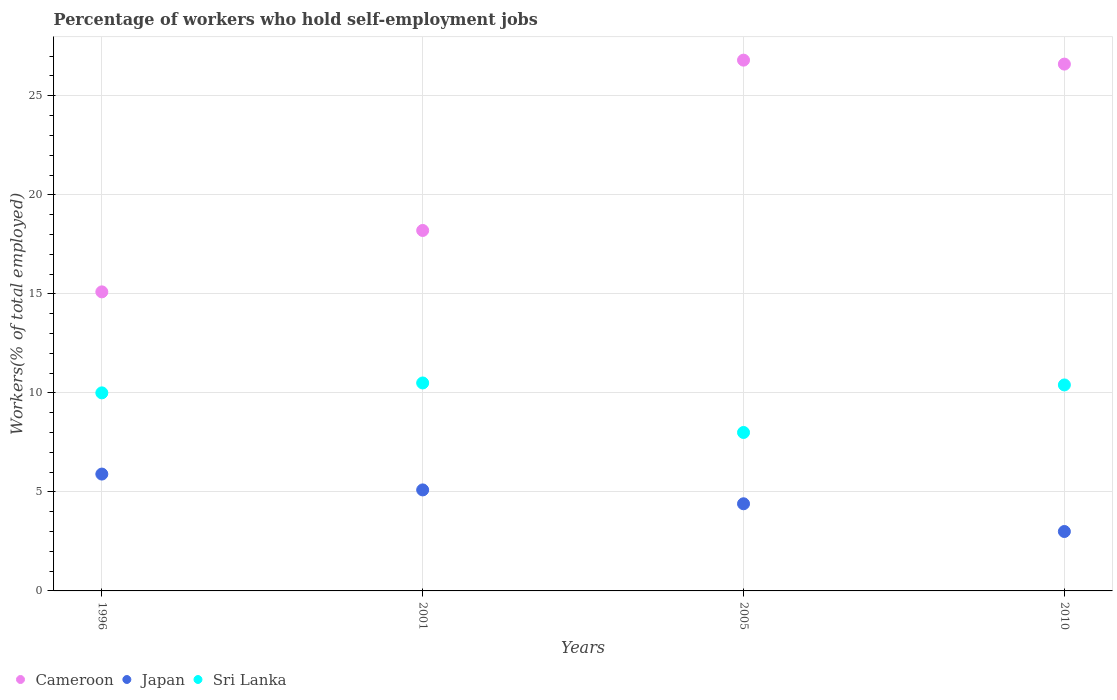Is the number of dotlines equal to the number of legend labels?
Ensure brevity in your answer.  Yes. What is the percentage of self-employed workers in Cameroon in 2010?
Your response must be concise. 26.6. Across all years, what is the maximum percentage of self-employed workers in Japan?
Provide a succinct answer. 5.9. Across all years, what is the minimum percentage of self-employed workers in Cameroon?
Your answer should be very brief. 15.1. In which year was the percentage of self-employed workers in Japan maximum?
Offer a very short reply. 1996. In which year was the percentage of self-employed workers in Japan minimum?
Your answer should be very brief. 2010. What is the total percentage of self-employed workers in Sri Lanka in the graph?
Ensure brevity in your answer.  38.9. What is the difference between the percentage of self-employed workers in Sri Lanka in 2001 and that in 2010?
Your answer should be very brief. 0.1. What is the difference between the percentage of self-employed workers in Cameroon in 2001 and the percentage of self-employed workers in Sri Lanka in 1996?
Your answer should be very brief. 8.2. What is the average percentage of self-employed workers in Japan per year?
Give a very brief answer. 4.6. In the year 2005, what is the difference between the percentage of self-employed workers in Sri Lanka and percentage of self-employed workers in Japan?
Your response must be concise. 3.6. In how many years, is the percentage of self-employed workers in Cameroon greater than 14 %?
Ensure brevity in your answer.  4. What is the ratio of the percentage of self-employed workers in Cameroon in 1996 to that in 2005?
Keep it short and to the point. 0.56. Is the difference between the percentage of self-employed workers in Sri Lanka in 2001 and 2010 greater than the difference between the percentage of self-employed workers in Japan in 2001 and 2010?
Provide a short and direct response. No. What is the difference between the highest and the second highest percentage of self-employed workers in Sri Lanka?
Make the answer very short. 0.1. What is the difference between the highest and the lowest percentage of self-employed workers in Cameroon?
Make the answer very short. 11.7. In how many years, is the percentage of self-employed workers in Japan greater than the average percentage of self-employed workers in Japan taken over all years?
Give a very brief answer. 2. Is the sum of the percentage of self-employed workers in Japan in 1996 and 2001 greater than the maximum percentage of self-employed workers in Sri Lanka across all years?
Offer a very short reply. Yes. Does the percentage of self-employed workers in Cameroon monotonically increase over the years?
Keep it short and to the point. No. Is the percentage of self-employed workers in Japan strictly greater than the percentage of self-employed workers in Sri Lanka over the years?
Offer a very short reply. No. How many dotlines are there?
Offer a terse response. 3. How many years are there in the graph?
Keep it short and to the point. 4. Does the graph contain any zero values?
Your response must be concise. No. Does the graph contain grids?
Provide a succinct answer. Yes. Where does the legend appear in the graph?
Provide a succinct answer. Bottom left. How many legend labels are there?
Offer a terse response. 3. How are the legend labels stacked?
Ensure brevity in your answer.  Horizontal. What is the title of the graph?
Your response must be concise. Percentage of workers who hold self-employment jobs. Does "Brazil" appear as one of the legend labels in the graph?
Offer a terse response. No. What is the label or title of the Y-axis?
Offer a very short reply. Workers(% of total employed). What is the Workers(% of total employed) of Cameroon in 1996?
Give a very brief answer. 15.1. What is the Workers(% of total employed) of Japan in 1996?
Your answer should be very brief. 5.9. What is the Workers(% of total employed) of Sri Lanka in 1996?
Give a very brief answer. 10. What is the Workers(% of total employed) of Cameroon in 2001?
Provide a succinct answer. 18.2. What is the Workers(% of total employed) of Japan in 2001?
Give a very brief answer. 5.1. What is the Workers(% of total employed) of Sri Lanka in 2001?
Your response must be concise. 10.5. What is the Workers(% of total employed) in Cameroon in 2005?
Offer a very short reply. 26.8. What is the Workers(% of total employed) of Japan in 2005?
Make the answer very short. 4.4. What is the Workers(% of total employed) in Sri Lanka in 2005?
Your answer should be very brief. 8. What is the Workers(% of total employed) of Cameroon in 2010?
Your response must be concise. 26.6. What is the Workers(% of total employed) of Sri Lanka in 2010?
Offer a very short reply. 10.4. Across all years, what is the maximum Workers(% of total employed) of Cameroon?
Provide a short and direct response. 26.8. Across all years, what is the maximum Workers(% of total employed) in Japan?
Provide a succinct answer. 5.9. Across all years, what is the minimum Workers(% of total employed) of Cameroon?
Offer a very short reply. 15.1. Across all years, what is the minimum Workers(% of total employed) in Japan?
Offer a terse response. 3. Across all years, what is the minimum Workers(% of total employed) of Sri Lanka?
Give a very brief answer. 8. What is the total Workers(% of total employed) in Cameroon in the graph?
Provide a short and direct response. 86.7. What is the total Workers(% of total employed) of Japan in the graph?
Make the answer very short. 18.4. What is the total Workers(% of total employed) in Sri Lanka in the graph?
Offer a very short reply. 38.9. What is the difference between the Workers(% of total employed) in Cameroon in 1996 and that in 2001?
Your answer should be very brief. -3.1. What is the difference between the Workers(% of total employed) in Sri Lanka in 1996 and that in 2001?
Give a very brief answer. -0.5. What is the difference between the Workers(% of total employed) of Cameroon in 1996 and that in 2005?
Provide a succinct answer. -11.7. What is the difference between the Workers(% of total employed) of Japan in 1996 and that in 2005?
Your answer should be compact. 1.5. What is the difference between the Workers(% of total employed) of Sri Lanka in 1996 and that in 2010?
Give a very brief answer. -0.4. What is the difference between the Workers(% of total employed) in Sri Lanka in 2001 and that in 2005?
Your response must be concise. 2.5. What is the difference between the Workers(% of total employed) in Cameroon in 2001 and that in 2010?
Provide a short and direct response. -8.4. What is the difference between the Workers(% of total employed) in Japan in 2001 and that in 2010?
Your answer should be compact. 2.1. What is the difference between the Workers(% of total employed) in Sri Lanka in 2001 and that in 2010?
Your answer should be very brief. 0.1. What is the difference between the Workers(% of total employed) in Cameroon in 1996 and the Workers(% of total employed) in Japan in 2001?
Your response must be concise. 10. What is the difference between the Workers(% of total employed) of Cameroon in 1996 and the Workers(% of total employed) of Japan in 2005?
Make the answer very short. 10.7. What is the difference between the Workers(% of total employed) in Japan in 1996 and the Workers(% of total employed) in Sri Lanka in 2005?
Your answer should be very brief. -2.1. What is the difference between the Workers(% of total employed) in Japan in 1996 and the Workers(% of total employed) in Sri Lanka in 2010?
Make the answer very short. -4.5. What is the difference between the Workers(% of total employed) in Japan in 2001 and the Workers(% of total employed) in Sri Lanka in 2005?
Make the answer very short. -2.9. What is the difference between the Workers(% of total employed) in Cameroon in 2001 and the Workers(% of total employed) in Sri Lanka in 2010?
Provide a short and direct response. 7.8. What is the difference between the Workers(% of total employed) of Cameroon in 2005 and the Workers(% of total employed) of Japan in 2010?
Provide a short and direct response. 23.8. What is the difference between the Workers(% of total employed) in Cameroon in 2005 and the Workers(% of total employed) in Sri Lanka in 2010?
Offer a terse response. 16.4. What is the average Workers(% of total employed) in Cameroon per year?
Offer a terse response. 21.68. What is the average Workers(% of total employed) of Japan per year?
Offer a terse response. 4.6. What is the average Workers(% of total employed) in Sri Lanka per year?
Your response must be concise. 9.72. In the year 1996, what is the difference between the Workers(% of total employed) in Cameroon and Workers(% of total employed) in Sri Lanka?
Your response must be concise. 5.1. In the year 1996, what is the difference between the Workers(% of total employed) of Japan and Workers(% of total employed) of Sri Lanka?
Make the answer very short. -4.1. In the year 2001, what is the difference between the Workers(% of total employed) of Cameroon and Workers(% of total employed) of Sri Lanka?
Provide a succinct answer. 7.7. In the year 2001, what is the difference between the Workers(% of total employed) in Japan and Workers(% of total employed) in Sri Lanka?
Provide a short and direct response. -5.4. In the year 2005, what is the difference between the Workers(% of total employed) of Cameroon and Workers(% of total employed) of Japan?
Offer a terse response. 22.4. In the year 2010, what is the difference between the Workers(% of total employed) of Cameroon and Workers(% of total employed) of Japan?
Ensure brevity in your answer.  23.6. In the year 2010, what is the difference between the Workers(% of total employed) of Japan and Workers(% of total employed) of Sri Lanka?
Give a very brief answer. -7.4. What is the ratio of the Workers(% of total employed) in Cameroon in 1996 to that in 2001?
Your response must be concise. 0.83. What is the ratio of the Workers(% of total employed) in Japan in 1996 to that in 2001?
Your answer should be very brief. 1.16. What is the ratio of the Workers(% of total employed) in Cameroon in 1996 to that in 2005?
Make the answer very short. 0.56. What is the ratio of the Workers(% of total employed) of Japan in 1996 to that in 2005?
Give a very brief answer. 1.34. What is the ratio of the Workers(% of total employed) of Cameroon in 1996 to that in 2010?
Keep it short and to the point. 0.57. What is the ratio of the Workers(% of total employed) of Japan in 1996 to that in 2010?
Your answer should be compact. 1.97. What is the ratio of the Workers(% of total employed) of Sri Lanka in 1996 to that in 2010?
Provide a succinct answer. 0.96. What is the ratio of the Workers(% of total employed) of Cameroon in 2001 to that in 2005?
Provide a succinct answer. 0.68. What is the ratio of the Workers(% of total employed) in Japan in 2001 to that in 2005?
Your answer should be compact. 1.16. What is the ratio of the Workers(% of total employed) of Sri Lanka in 2001 to that in 2005?
Provide a succinct answer. 1.31. What is the ratio of the Workers(% of total employed) in Cameroon in 2001 to that in 2010?
Offer a very short reply. 0.68. What is the ratio of the Workers(% of total employed) in Sri Lanka in 2001 to that in 2010?
Give a very brief answer. 1.01. What is the ratio of the Workers(% of total employed) of Cameroon in 2005 to that in 2010?
Keep it short and to the point. 1.01. What is the ratio of the Workers(% of total employed) of Japan in 2005 to that in 2010?
Ensure brevity in your answer.  1.47. What is the ratio of the Workers(% of total employed) in Sri Lanka in 2005 to that in 2010?
Provide a short and direct response. 0.77. What is the difference between the highest and the second highest Workers(% of total employed) of Cameroon?
Make the answer very short. 0.2. What is the difference between the highest and the lowest Workers(% of total employed) of Cameroon?
Your answer should be compact. 11.7. What is the difference between the highest and the lowest Workers(% of total employed) in Sri Lanka?
Make the answer very short. 2.5. 